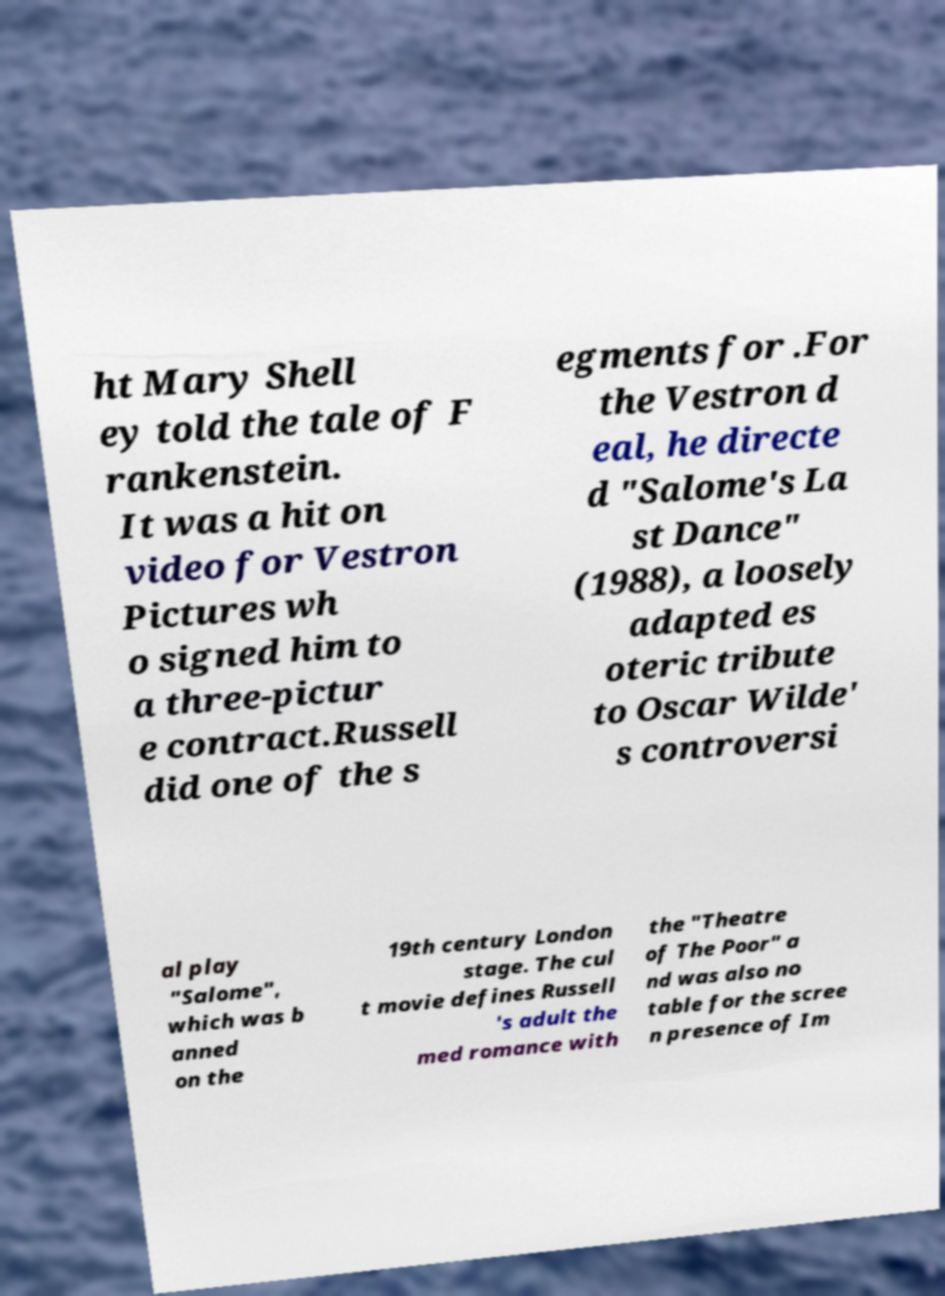Please read and relay the text visible in this image. What does it say? ht Mary Shell ey told the tale of F rankenstein. It was a hit on video for Vestron Pictures wh o signed him to a three-pictur e contract.Russell did one of the s egments for .For the Vestron d eal, he directe d "Salome's La st Dance" (1988), a loosely adapted es oteric tribute to Oscar Wilde' s controversi al play "Salome", which was b anned on the 19th century London stage. The cul t movie defines Russell 's adult the med romance with the "Theatre of The Poor" a nd was also no table for the scree n presence of Im 